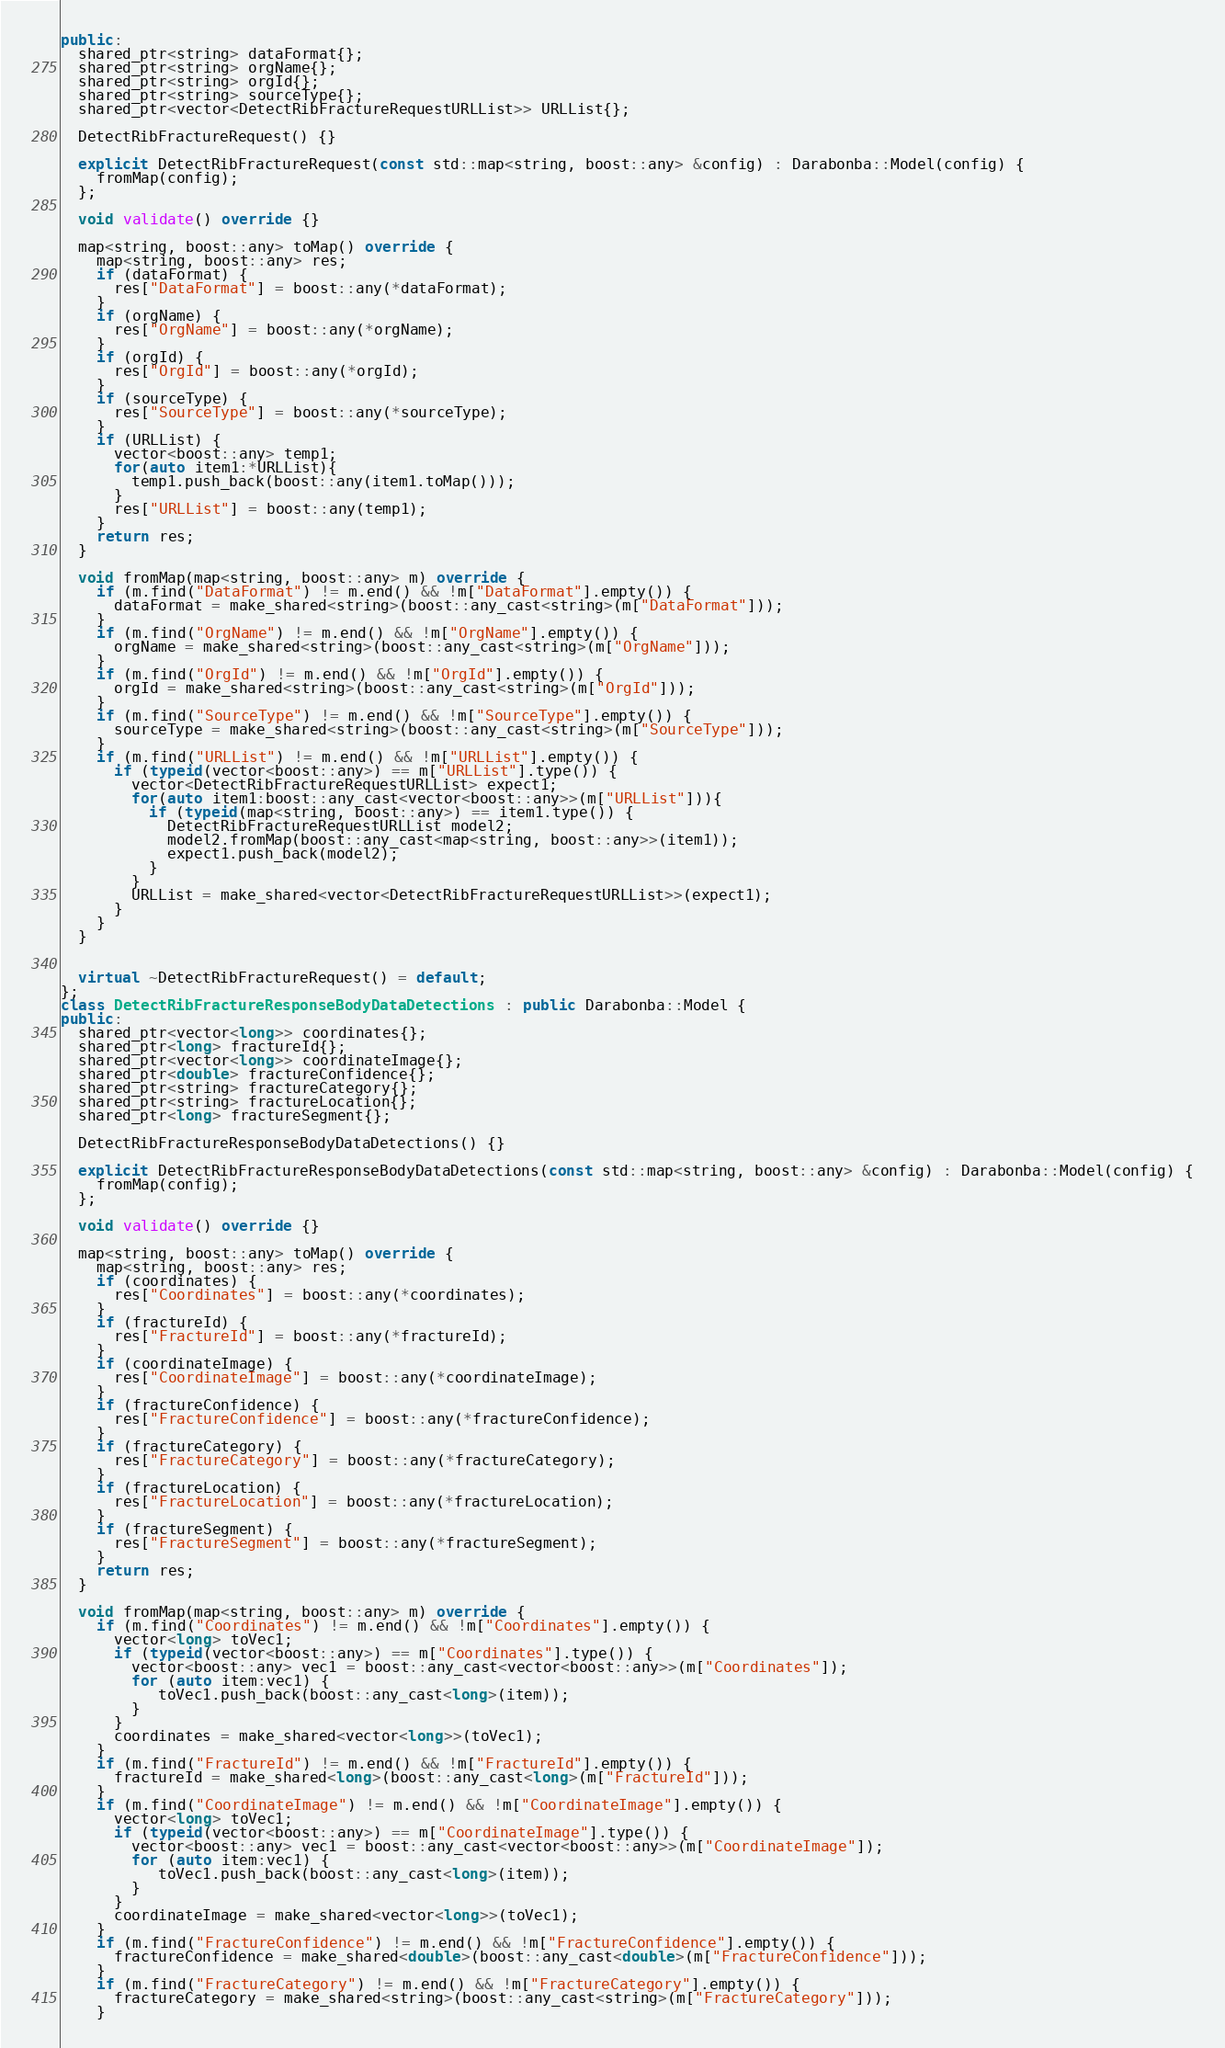<code> <loc_0><loc_0><loc_500><loc_500><_C++_>public:
  shared_ptr<string> dataFormat{};
  shared_ptr<string> orgName{};
  shared_ptr<string> orgId{};
  shared_ptr<string> sourceType{};
  shared_ptr<vector<DetectRibFractureRequestURLList>> URLList{};

  DetectRibFractureRequest() {}

  explicit DetectRibFractureRequest(const std::map<string, boost::any> &config) : Darabonba::Model(config) {
    fromMap(config);
  };

  void validate() override {}

  map<string, boost::any> toMap() override {
    map<string, boost::any> res;
    if (dataFormat) {
      res["DataFormat"] = boost::any(*dataFormat);
    }
    if (orgName) {
      res["OrgName"] = boost::any(*orgName);
    }
    if (orgId) {
      res["OrgId"] = boost::any(*orgId);
    }
    if (sourceType) {
      res["SourceType"] = boost::any(*sourceType);
    }
    if (URLList) {
      vector<boost::any> temp1;
      for(auto item1:*URLList){
        temp1.push_back(boost::any(item1.toMap()));
      }
      res["URLList"] = boost::any(temp1);
    }
    return res;
  }

  void fromMap(map<string, boost::any> m) override {
    if (m.find("DataFormat") != m.end() && !m["DataFormat"].empty()) {
      dataFormat = make_shared<string>(boost::any_cast<string>(m["DataFormat"]));
    }
    if (m.find("OrgName") != m.end() && !m["OrgName"].empty()) {
      orgName = make_shared<string>(boost::any_cast<string>(m["OrgName"]));
    }
    if (m.find("OrgId") != m.end() && !m["OrgId"].empty()) {
      orgId = make_shared<string>(boost::any_cast<string>(m["OrgId"]));
    }
    if (m.find("SourceType") != m.end() && !m["SourceType"].empty()) {
      sourceType = make_shared<string>(boost::any_cast<string>(m["SourceType"]));
    }
    if (m.find("URLList") != m.end() && !m["URLList"].empty()) {
      if (typeid(vector<boost::any>) == m["URLList"].type()) {
        vector<DetectRibFractureRequestURLList> expect1;
        for(auto item1:boost::any_cast<vector<boost::any>>(m["URLList"])){
          if (typeid(map<string, boost::any>) == item1.type()) {
            DetectRibFractureRequestURLList model2;
            model2.fromMap(boost::any_cast<map<string, boost::any>>(item1));
            expect1.push_back(model2);
          }
        }
        URLList = make_shared<vector<DetectRibFractureRequestURLList>>(expect1);
      }
    }
  }


  virtual ~DetectRibFractureRequest() = default;
};
class DetectRibFractureResponseBodyDataDetections : public Darabonba::Model {
public:
  shared_ptr<vector<long>> coordinates{};
  shared_ptr<long> fractureId{};
  shared_ptr<vector<long>> coordinateImage{};
  shared_ptr<double> fractureConfidence{};
  shared_ptr<string> fractureCategory{};
  shared_ptr<string> fractureLocation{};
  shared_ptr<long> fractureSegment{};

  DetectRibFractureResponseBodyDataDetections() {}

  explicit DetectRibFractureResponseBodyDataDetections(const std::map<string, boost::any> &config) : Darabonba::Model(config) {
    fromMap(config);
  };

  void validate() override {}

  map<string, boost::any> toMap() override {
    map<string, boost::any> res;
    if (coordinates) {
      res["Coordinates"] = boost::any(*coordinates);
    }
    if (fractureId) {
      res["FractureId"] = boost::any(*fractureId);
    }
    if (coordinateImage) {
      res["CoordinateImage"] = boost::any(*coordinateImage);
    }
    if (fractureConfidence) {
      res["FractureConfidence"] = boost::any(*fractureConfidence);
    }
    if (fractureCategory) {
      res["FractureCategory"] = boost::any(*fractureCategory);
    }
    if (fractureLocation) {
      res["FractureLocation"] = boost::any(*fractureLocation);
    }
    if (fractureSegment) {
      res["FractureSegment"] = boost::any(*fractureSegment);
    }
    return res;
  }

  void fromMap(map<string, boost::any> m) override {
    if (m.find("Coordinates") != m.end() && !m["Coordinates"].empty()) {
      vector<long> toVec1;
      if (typeid(vector<boost::any>) == m["Coordinates"].type()) {
        vector<boost::any> vec1 = boost::any_cast<vector<boost::any>>(m["Coordinates"]);
        for (auto item:vec1) {
           toVec1.push_back(boost::any_cast<long>(item));
        }
      }
      coordinates = make_shared<vector<long>>(toVec1);
    }
    if (m.find("FractureId") != m.end() && !m["FractureId"].empty()) {
      fractureId = make_shared<long>(boost::any_cast<long>(m["FractureId"]));
    }
    if (m.find("CoordinateImage") != m.end() && !m["CoordinateImage"].empty()) {
      vector<long> toVec1;
      if (typeid(vector<boost::any>) == m["CoordinateImage"].type()) {
        vector<boost::any> vec1 = boost::any_cast<vector<boost::any>>(m["CoordinateImage"]);
        for (auto item:vec1) {
           toVec1.push_back(boost::any_cast<long>(item));
        }
      }
      coordinateImage = make_shared<vector<long>>(toVec1);
    }
    if (m.find("FractureConfidence") != m.end() && !m["FractureConfidence"].empty()) {
      fractureConfidence = make_shared<double>(boost::any_cast<double>(m["FractureConfidence"]));
    }
    if (m.find("FractureCategory") != m.end() && !m["FractureCategory"].empty()) {
      fractureCategory = make_shared<string>(boost::any_cast<string>(m["FractureCategory"]));
    }</code> 